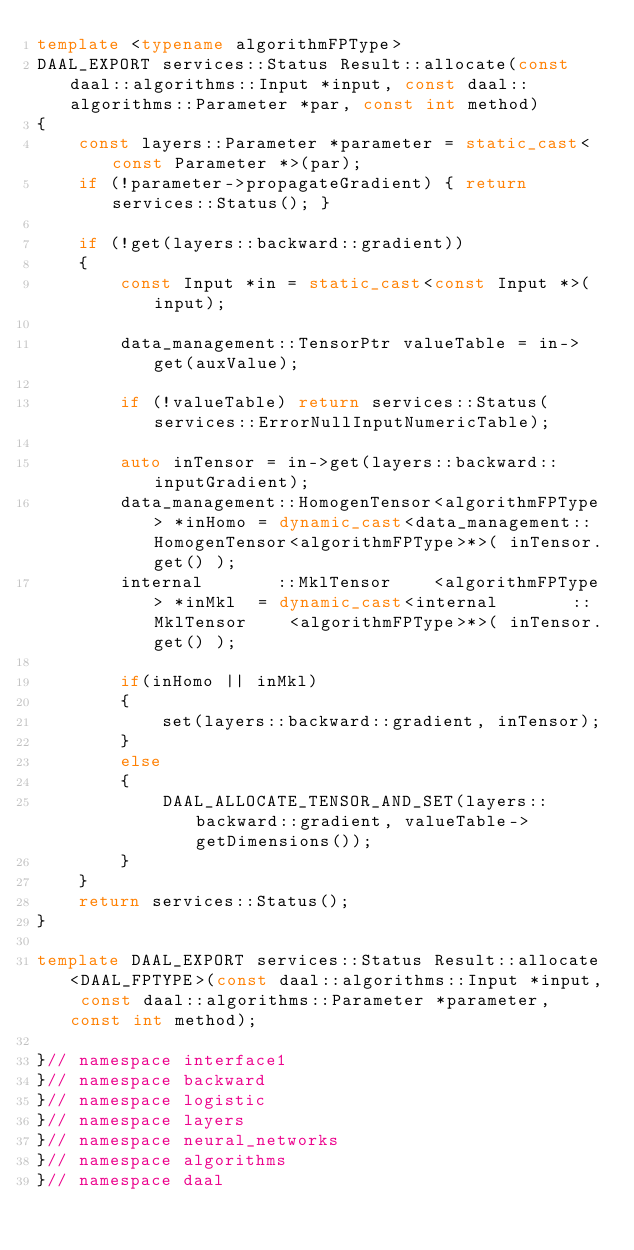<code> <loc_0><loc_0><loc_500><loc_500><_C++_>template <typename algorithmFPType>
DAAL_EXPORT services::Status Result::allocate(const daal::algorithms::Input *input, const daal::algorithms::Parameter *par, const int method)
{
    const layers::Parameter *parameter = static_cast<const Parameter *>(par);
    if (!parameter->propagateGradient) { return services::Status(); }

    if (!get(layers::backward::gradient))
    {
        const Input *in = static_cast<const Input *>(input);

        data_management::TensorPtr valueTable = in->get(auxValue);

        if (!valueTable) return services::Status(services::ErrorNullInputNumericTable);

        auto inTensor = in->get(layers::backward::inputGradient);
        data_management::HomogenTensor<algorithmFPType> *inHomo = dynamic_cast<data_management::HomogenTensor<algorithmFPType>*>( inTensor.get() );
        internal       ::MklTensor    <algorithmFPType> *inMkl  = dynamic_cast<internal       ::MklTensor    <algorithmFPType>*>( inTensor.get() );

        if(inHomo || inMkl)
        {
            set(layers::backward::gradient, inTensor);
        }
        else
        {
            DAAL_ALLOCATE_TENSOR_AND_SET(layers::backward::gradient, valueTable->getDimensions());
        }
    }
    return services::Status();
}

template DAAL_EXPORT services::Status Result::allocate<DAAL_FPTYPE>(const daal::algorithms::Input *input, const daal::algorithms::Parameter *parameter, const int method);

}// namespace interface1
}// namespace backward
}// namespace logistic
}// namespace layers
}// namespace neural_networks
}// namespace algorithms
}// namespace daal
</code> 